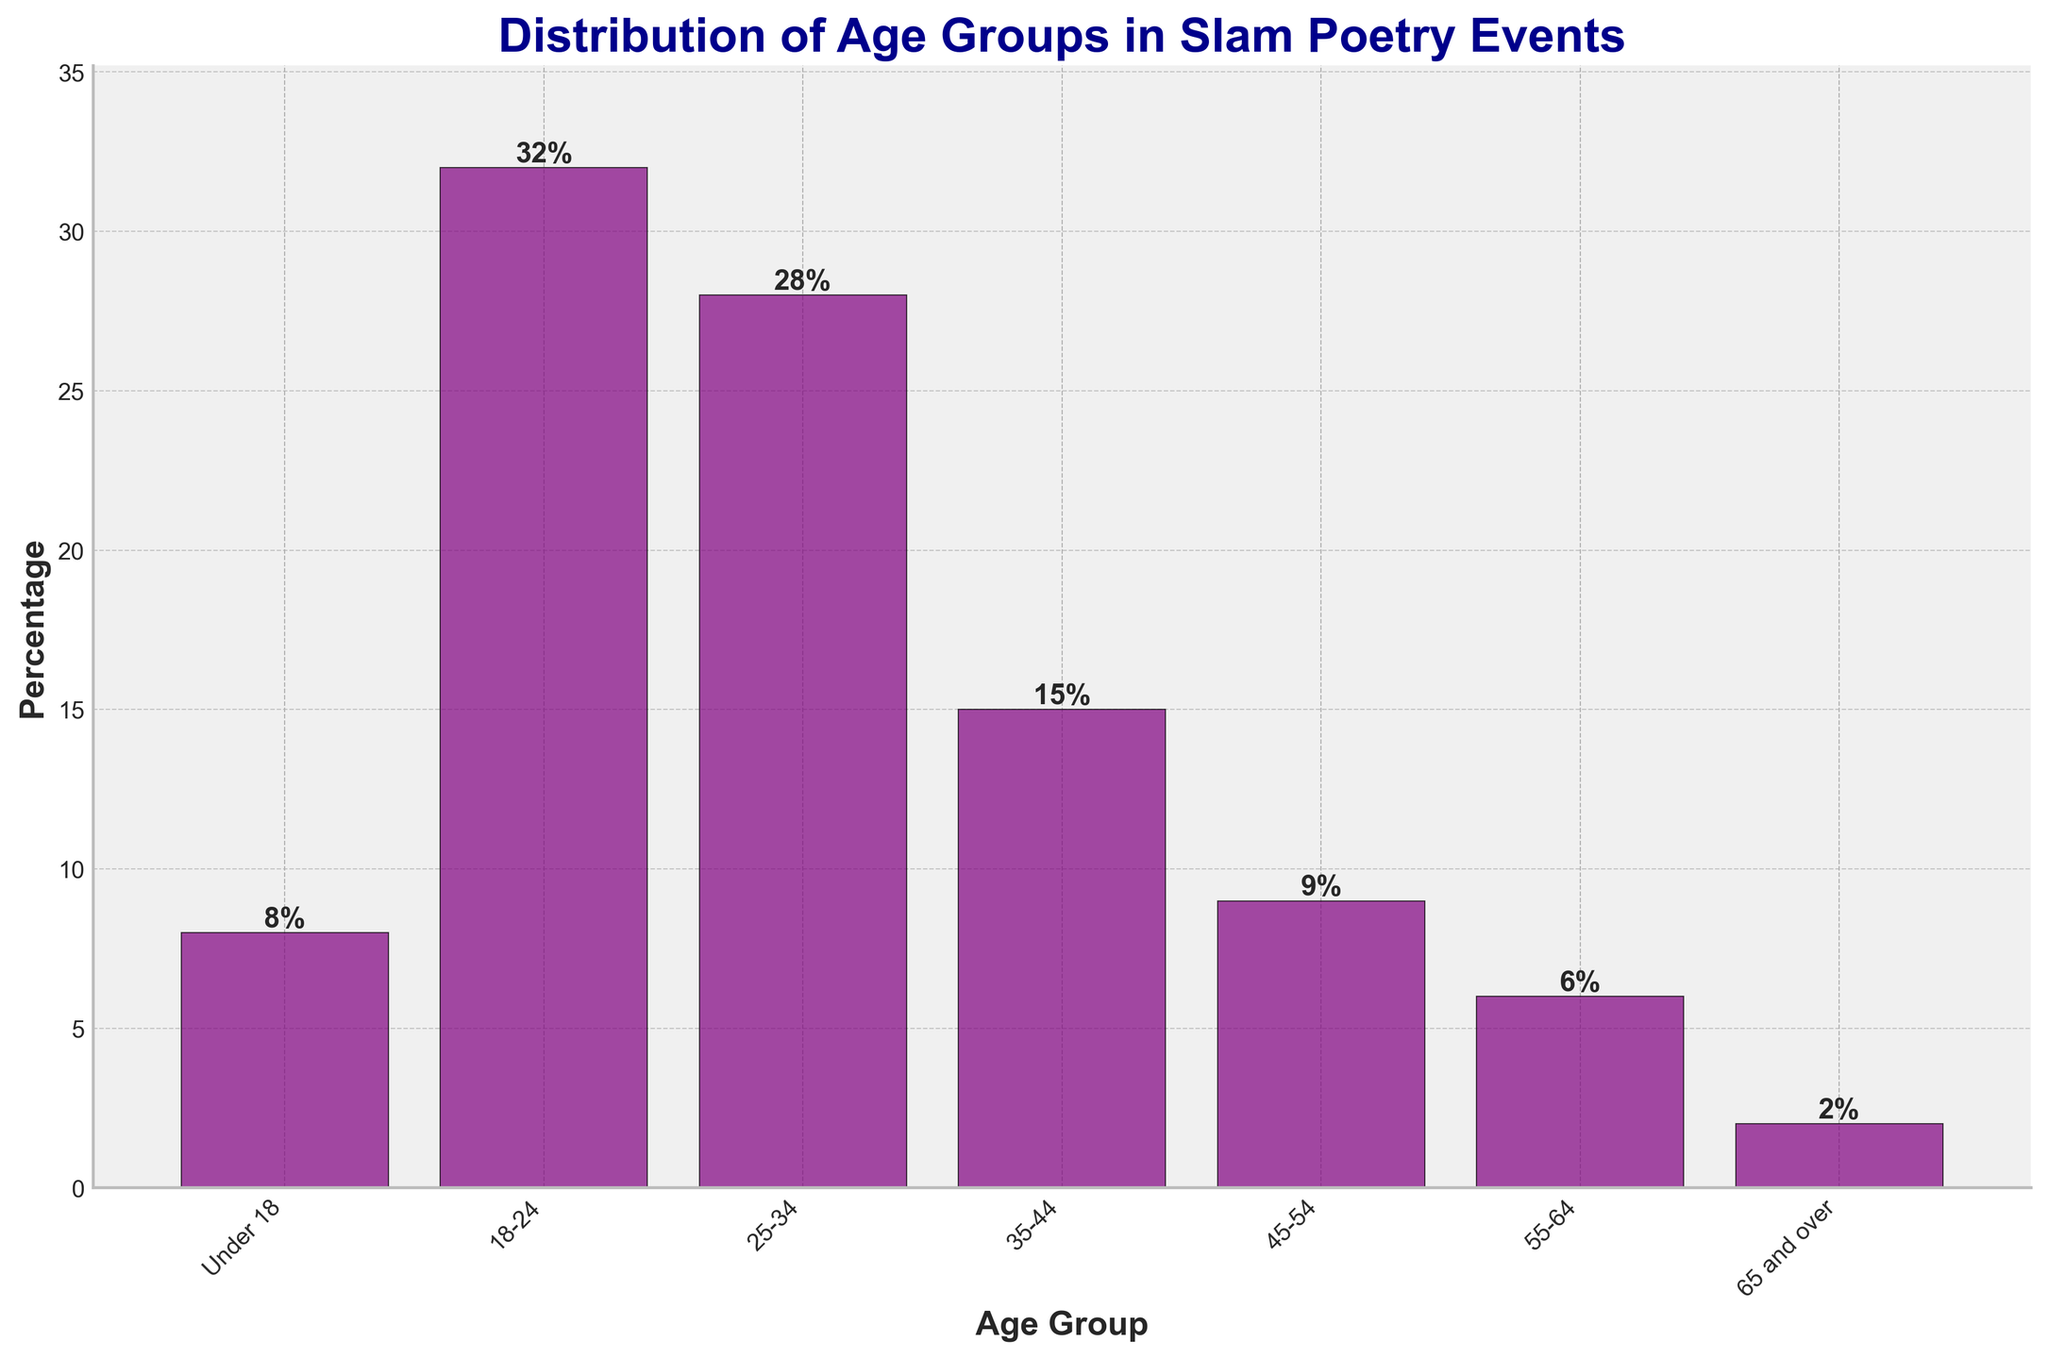What age group has the highest percentage of participants? The bar representing the 18-24 age group is the tallest and has a height labeled as 32%, indicating it has the highest percentage.
Answer: 18-24 Which age groups make up more than a quarter of the participants? The 18-24 and 25-34 age groups both have percentages above 25%. The 18-24 age group is 32%, and the 25-34 age group is 28%.
Answer: 18-24, 25-34 How do the percentages of the 45-54 and 55-64 age groups compare? The bar for the 45-54 age group is taller than that for the 55-64 age group. The 45-54 age group has a percentage of 9%, while the 55-64 age group has a percentage of 6%.
Answer: 45-54 > 55-64 What is the difference in percentage between the 25-34 and 35-44 age groups? The percentage for the 25-34 age group is 28%, and for the 35-44 age group, it is 15%. The difference is 28% - 15% = 13%.
Answer: 13% What is the total percentage of participants aged 18-24, 25-34, and 35-44 combined? Sum the percentages of these three groups: 32% + 28% + 15% = 75%.
Answer: 75% Which age group has the smallest percentage of participants? The bar for the 65 and over age group is the shortest with a height labeled as 2%, indicating it has the smallest percentage of participants.
Answer: 65 and over Is the percentage of participants aged under 18 greater than the percentage of participants aged 55-64? The bar for the under 18 age group is taller than the one for the 55-64 age group. The under 18 group has 8%, while the 55-64 group has 6%.
Answer: Yes By how much does the percentage of the 18-24 age group exceed the percentage of the 45-54 age group? The percentage for the 18-24 age group is 32%, and for the 45-54 age group, it is 9%. The excess is 32% - 9% = 23%.
Answer: 23% What is the average percentage of participants in the 45-54 and 65 and over age groups? Sum the percentages and divide by 2: (9% + 2%) / 2 = 5.5%.
Answer: 5.5% Is the sum of the percentages of the under 18 and 55-64 age groups less than the percentage of the 25-34 age group? Sum the percentages of the under 18 and 55-64 groups: 8% + 6% = 14%. The percentage of the 25-34 group is 28%, which is greater than 14%.
Answer: Yes 